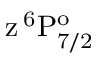Convert formula to latex. <formula><loc_0><loc_0><loc_500><loc_500>z \, ^ { 6 } P _ { 7 / 2 } ^ { o }</formula> 